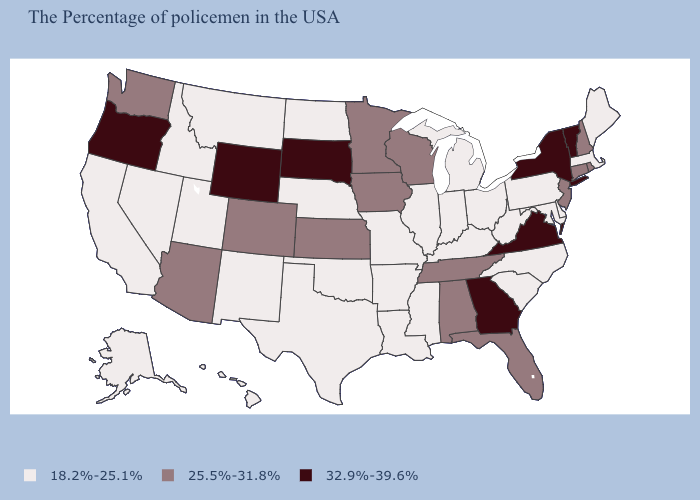Which states have the lowest value in the South?
Give a very brief answer. Delaware, Maryland, North Carolina, South Carolina, West Virginia, Kentucky, Mississippi, Louisiana, Arkansas, Oklahoma, Texas. Among the states that border Montana , does North Dakota have the highest value?
Short answer required. No. What is the value of California?
Answer briefly. 18.2%-25.1%. Which states have the lowest value in the South?
Answer briefly. Delaware, Maryland, North Carolina, South Carolina, West Virginia, Kentucky, Mississippi, Louisiana, Arkansas, Oklahoma, Texas. Is the legend a continuous bar?
Give a very brief answer. No. Name the states that have a value in the range 18.2%-25.1%?
Give a very brief answer. Maine, Massachusetts, Delaware, Maryland, Pennsylvania, North Carolina, South Carolina, West Virginia, Ohio, Michigan, Kentucky, Indiana, Illinois, Mississippi, Louisiana, Missouri, Arkansas, Nebraska, Oklahoma, Texas, North Dakota, New Mexico, Utah, Montana, Idaho, Nevada, California, Alaska, Hawaii. What is the value of Iowa?
Answer briefly. 25.5%-31.8%. Is the legend a continuous bar?
Short answer required. No. Which states have the lowest value in the USA?
Short answer required. Maine, Massachusetts, Delaware, Maryland, Pennsylvania, North Carolina, South Carolina, West Virginia, Ohio, Michigan, Kentucky, Indiana, Illinois, Mississippi, Louisiana, Missouri, Arkansas, Nebraska, Oklahoma, Texas, North Dakota, New Mexico, Utah, Montana, Idaho, Nevada, California, Alaska, Hawaii. What is the highest value in states that border New York?
Keep it brief. 32.9%-39.6%. Is the legend a continuous bar?
Short answer required. No. Name the states that have a value in the range 25.5%-31.8%?
Give a very brief answer. Rhode Island, New Hampshire, Connecticut, New Jersey, Florida, Alabama, Tennessee, Wisconsin, Minnesota, Iowa, Kansas, Colorado, Arizona, Washington. What is the value of Massachusetts?
Be succinct. 18.2%-25.1%. Does the map have missing data?
Keep it brief. No. Name the states that have a value in the range 18.2%-25.1%?
Answer briefly. Maine, Massachusetts, Delaware, Maryland, Pennsylvania, North Carolina, South Carolina, West Virginia, Ohio, Michigan, Kentucky, Indiana, Illinois, Mississippi, Louisiana, Missouri, Arkansas, Nebraska, Oklahoma, Texas, North Dakota, New Mexico, Utah, Montana, Idaho, Nevada, California, Alaska, Hawaii. 